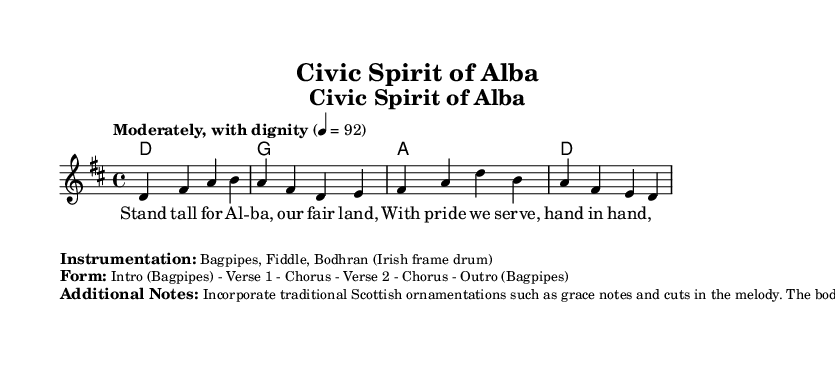What is the key signature of this music? The key signature is D major, which has two sharps (F# and C#). This can be determined from the key signature indicator at the beginning of the score, which shows the sharp signs.
Answer: D major What is the time signature of this music? The time signature is 4/4, indicated at the start of the score. This means there are four beats in each measure, and the quarter note gets one beat.
Answer: 4/4 What is the tempo marking given in the score? The tempo marking is "Moderately, with dignity" and is indicated in the score above the global section. It specifies how the piece should be played.
Answer: Moderately, with dignity What instruments are specified for this piece? The instruments listed in the score are Bagpipes, Fiddle, and Bodhran. This is noted as part of the additional information and serves as a guide for the orchestrations involved.
Answer: Bagpipes, Fiddle, Bodhran How many verses are in this composition? There are two verses in the lyrics, as indicated by the structure of the song in the score. The verses are labeled "Verse 1" and "Verse 2" before the repeated chorus.
Answer: 2 What traditional Scottish musical elements are suggested to incorporate? The additional notes emphasize the incorporation of traditional Scottish ornamentations such as grace notes and cuts, which are embellishments that add expression to the musical line.
Answer: Grace notes and cuts What is the overall form of the music? The overall form is an Intro (Bagpipes) followed by two verses and choruses and ends with an Outro (Bagpipes), as summarized in the markings. This indicates how the sections of the piece are organized.
Answer: Intro - Verse 1 - Chorus - Verse 2 - Chorus - Outro 